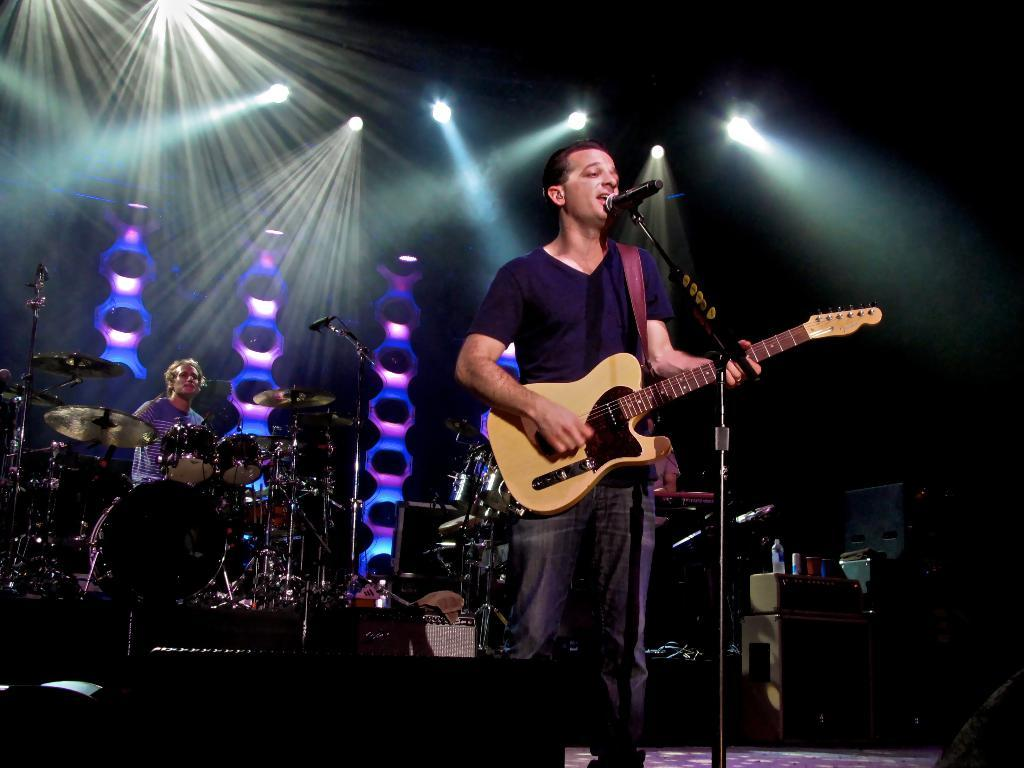What is the man in the background of the image doing? The man is holding a guitar and singing, as indicated by his open mouth. What object is the man holding in the image? The man is holding a guitar. What additional elements can be seen in the image? There are lighting and decorations visible in the image. Can you tell me how many cakes are on the table in the image? There is no table or cakes present in the image; it features a man holding a guitar and singing. 